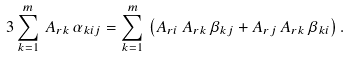Convert formula to latex. <formula><loc_0><loc_0><loc_500><loc_500>3 \sum _ { k = 1 } ^ { m } \, A _ { r k } \, \alpha _ { k i j } = \sum _ { k = 1 } ^ { m } \, \left ( A _ { r i } \, A _ { r k } \, \beta _ { k j } + A _ { r j } \, A _ { r k } \, \beta _ { k i } \right ) .</formula> 